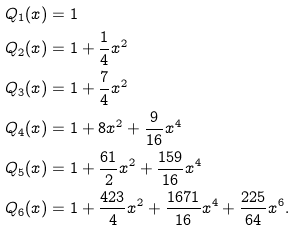<formula> <loc_0><loc_0><loc_500><loc_500>Q _ { 1 } ( x ) & = 1 \\ Q _ { 2 } ( x ) & = 1 + \frac { 1 } { 4 } x ^ { 2 } \\ Q _ { 3 } ( x ) & = 1 + \frac { 7 } { 4 } x ^ { 2 } \\ Q _ { 4 } ( x ) & = 1 + 8 x ^ { 2 } + \frac { 9 } { 1 6 } x ^ { 4 } \\ Q _ { 5 } ( x ) & = 1 + \frac { 6 1 } { 2 } x ^ { 2 } + \frac { 1 5 9 } { 1 6 } x ^ { 4 } \\ Q _ { 6 } ( x ) & = 1 + \frac { 4 2 3 } { 4 } x ^ { 2 } + \frac { 1 6 7 1 } { 1 6 } x ^ { 4 } + \frac { 2 2 5 } { 6 4 } x ^ { 6 } .</formula> 